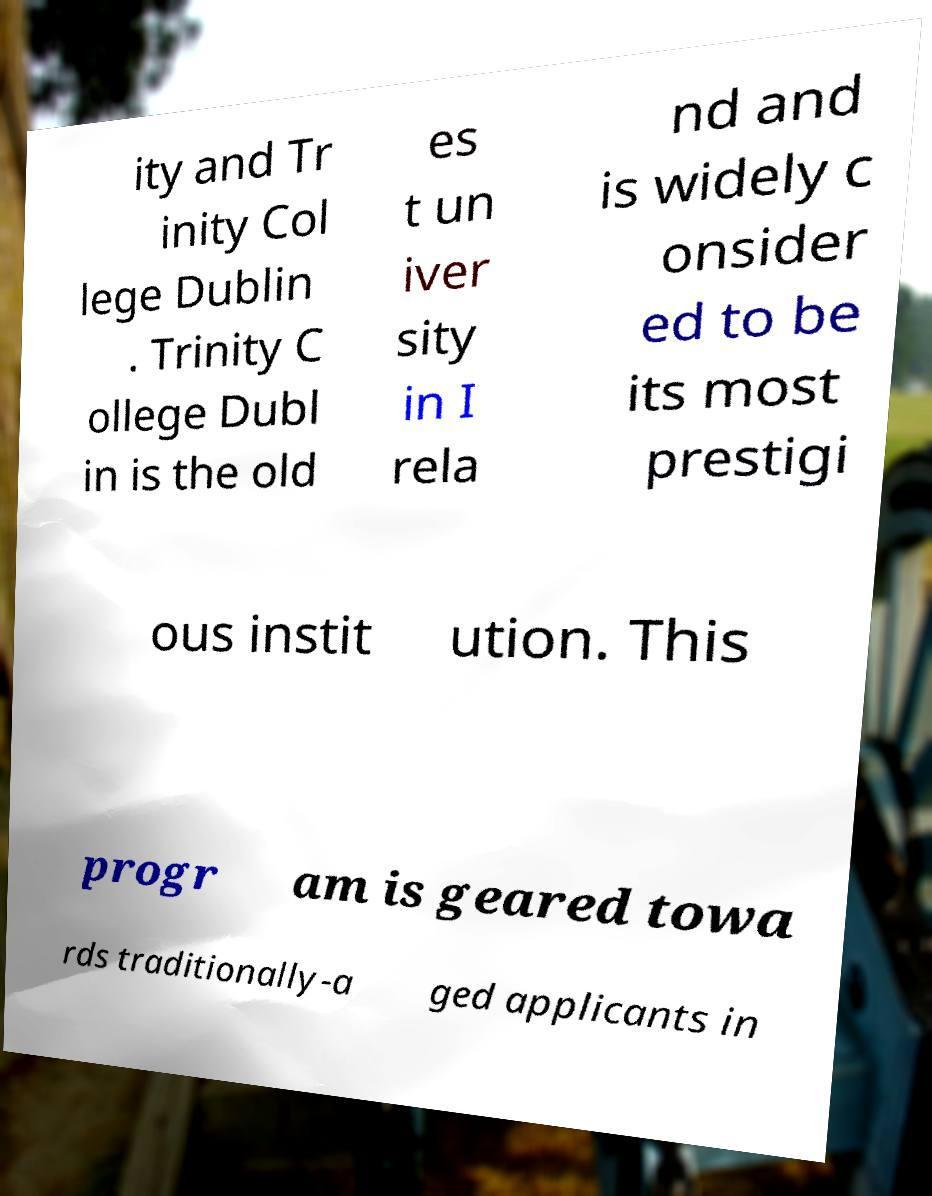Please read and relay the text visible in this image. What does it say? ity and Tr inity Col lege Dublin . Trinity C ollege Dubl in is the old es t un iver sity in I rela nd and is widely c onsider ed to be its most prestigi ous instit ution. This progr am is geared towa rds traditionally-a ged applicants in 